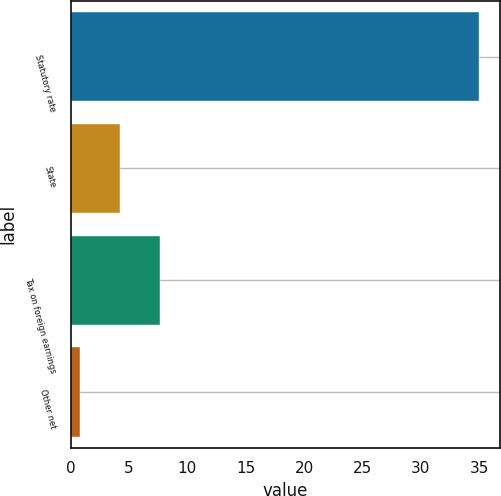Convert chart. <chart><loc_0><loc_0><loc_500><loc_500><bar_chart><fcel>Statutory rate<fcel>State<fcel>Tax on foreign earnings<fcel>Other net<nl><fcel>35<fcel>4.22<fcel>7.64<fcel>0.8<nl></chart> 